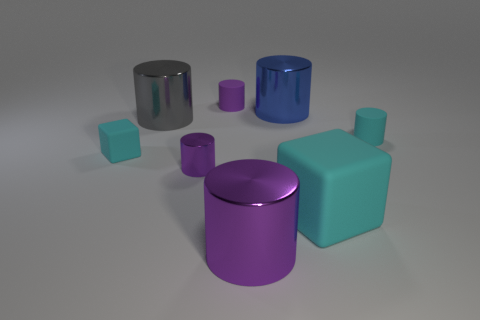The small object that is the same color as the tiny matte cube is what shape?
Your response must be concise. Cylinder. There is a block that is right of the tiny purple rubber thing; is its color the same as the tiny matte cube?
Keep it short and to the point. Yes. There is a cyan block that is to the right of the purple rubber cylinder; is its size the same as the blue cylinder?
Provide a short and direct response. Yes. What shape is the gray thing?
Make the answer very short. Cylinder. How many small rubber things are the same shape as the big gray shiny thing?
Your answer should be compact. 2. What number of things are to the right of the large cyan matte thing and in front of the large cyan block?
Make the answer very short. 0. What color is the tiny shiny thing?
Your response must be concise. Purple. Is there a big gray sphere that has the same material as the big gray object?
Offer a terse response. No. Are there any big metal cylinders that are in front of the small cyan thing that is in front of the matte cylinder to the right of the large blue metal cylinder?
Offer a very short reply. Yes. Are there any purple shiny cylinders behind the tiny purple shiny cylinder?
Provide a succinct answer. No. 